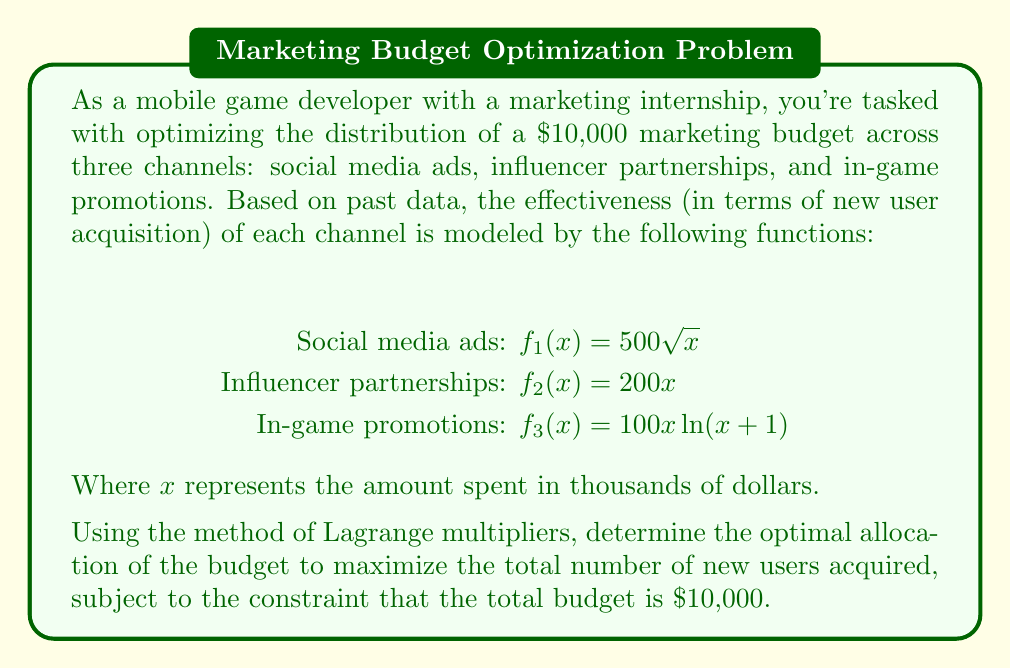Solve this math problem. To solve this problem using the method of Lagrange multipliers, we follow these steps:

1) First, let's define our objective function and constraint:

   Objective function: $F(x_1, x_2, x_3) = 500\sqrt{x_1} + 200x_2 + 100x_3\ln(x_3+1)$
   Constraint: $g(x_1, x_2, x_3) = x_1 + x_2 + x_3 - 10 = 0$

2) Now, we form the Lagrangian function:

   $L(x_1, x_2, x_3, \lambda) = F(x_1, x_2, x_3) - \lambda g(x_1, x_2, x_3)$
   $= 500\sqrt{x_1} + 200x_2 + 100x_3\ln(x_3+1) - \lambda(x_1 + x_2 + x_3 - 10)$

3) We take partial derivatives and set them equal to zero:

   $\frac{\partial L}{\partial x_1} = \frac{250}{\sqrt{x_1}} - \lambda = 0$
   $\frac{\partial L}{\partial x_2} = 200 - \lambda = 0$
   $\frac{\partial L}{\partial x_3} = 100\ln(x_3+1) + \frac{100x_3}{x_3+1} - \lambda = 0$
   $\frac{\partial L}{\partial \lambda} = x_1 + x_2 + x_3 - 10 = 0$

4) From the second equation, we can see that $\lambda = 200$. Substituting this into the first equation:

   $\frac{250}{\sqrt{x_1}} = 200$
   $x_1 = (\frac{250}{200})^2 = 1.5625$

5) For $x_3$, we need to solve:

   $100\ln(x_3+1) + \frac{100x_3}{x_3+1} = 200$

   This is a transcendental equation and doesn't have a simple algebraic solution. We can solve it numerically to get $x_3 \approx 2.8729$.

6) Finally, we can find $x_2$ using the constraint equation:

   $x_2 = 10 - x_1 - x_3 = 10 - 1.5625 - 2.8729 = 5.5646$

Therefore, the optimal allocation is:

Social media ads: $1,562.50
Influencer partnerships: $5,564.60
In-game promotions: $2,872.90
Answer: The optimal allocation of the $10,000 budget is:
Social media ads: $1,562.50
Influencer partnerships: $5,564.60
In-game promotions: $2,872.90 